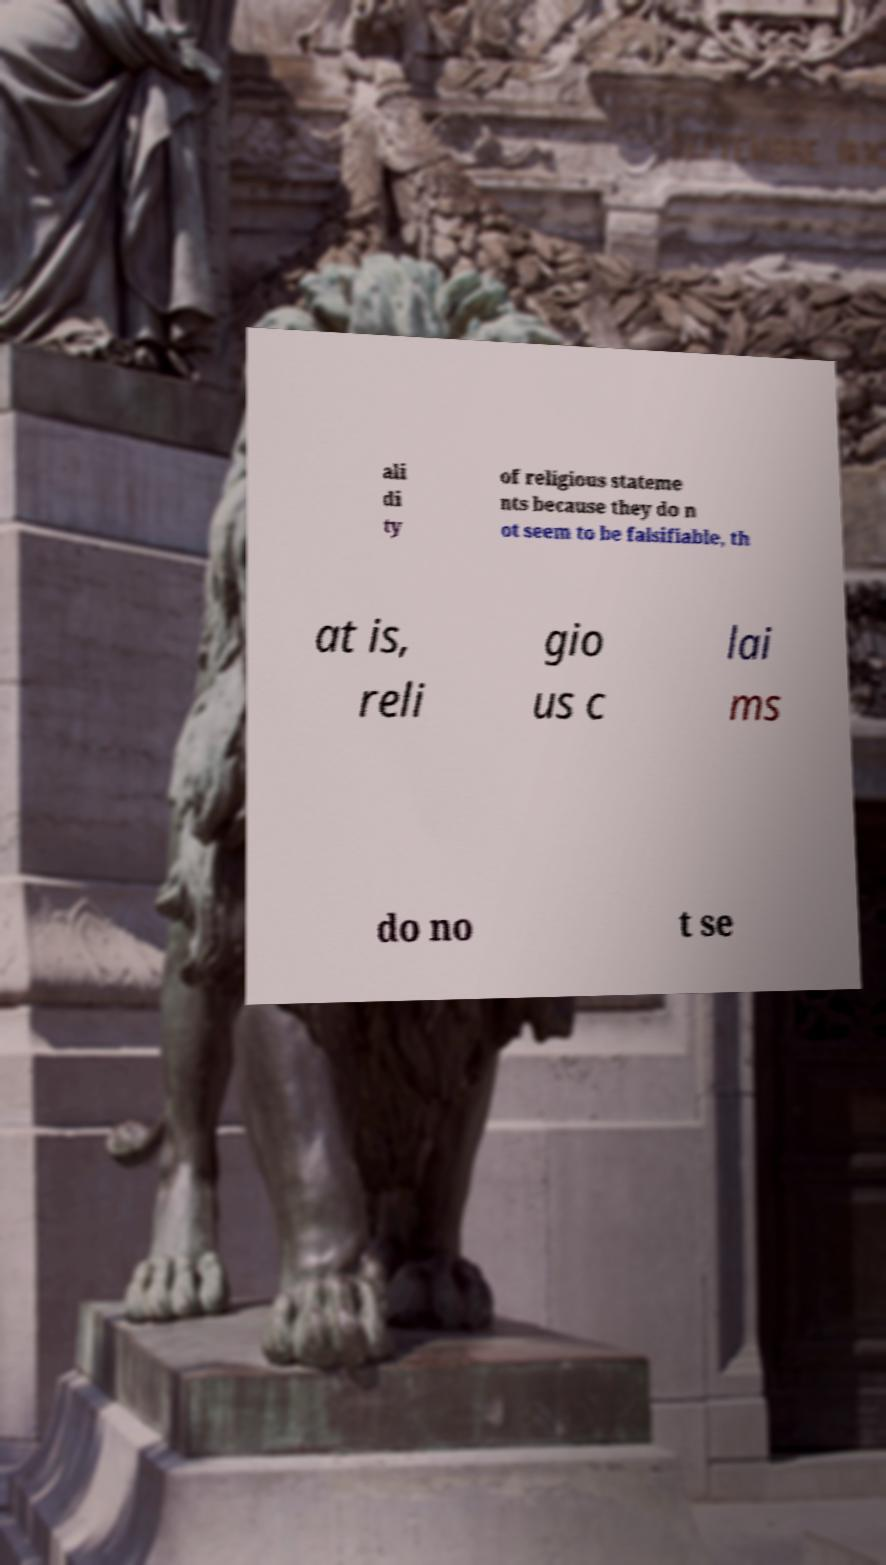For documentation purposes, I need the text within this image transcribed. Could you provide that? ali di ty of religious stateme nts because they do n ot seem to be falsifiable, th at is, reli gio us c lai ms do no t se 